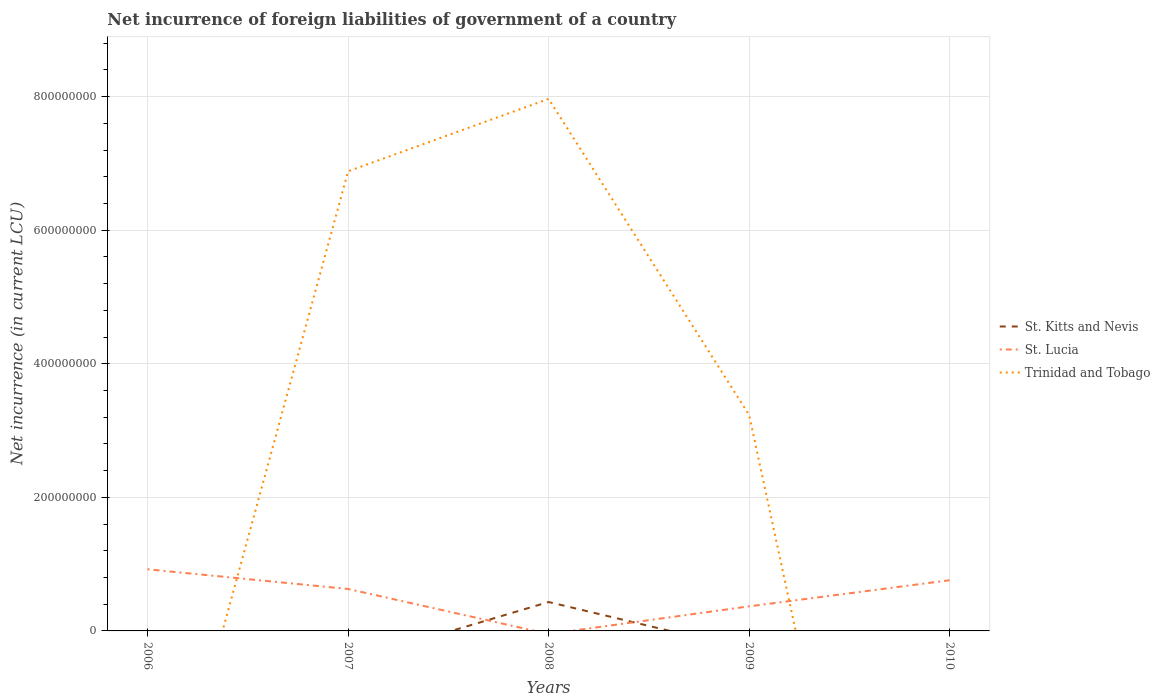How many different coloured lines are there?
Ensure brevity in your answer.  3. Across all years, what is the maximum net incurrence of foreign liabilities in St. Kitts and Nevis?
Make the answer very short. 0. What is the total net incurrence of foreign liabilities in Trinidad and Tobago in the graph?
Give a very brief answer. 4.73e+08. What is the difference between the highest and the second highest net incurrence of foreign liabilities in Trinidad and Tobago?
Make the answer very short. 7.97e+08. Is the net incurrence of foreign liabilities in Trinidad and Tobago strictly greater than the net incurrence of foreign liabilities in St. Kitts and Nevis over the years?
Your answer should be compact. No. How many lines are there?
Provide a succinct answer. 3. How many years are there in the graph?
Provide a short and direct response. 5. What is the difference between two consecutive major ticks on the Y-axis?
Provide a short and direct response. 2.00e+08. Are the values on the major ticks of Y-axis written in scientific E-notation?
Make the answer very short. No. Does the graph contain any zero values?
Offer a terse response. Yes. Does the graph contain grids?
Keep it short and to the point. Yes. Where does the legend appear in the graph?
Keep it short and to the point. Center right. What is the title of the graph?
Give a very brief answer. Net incurrence of foreign liabilities of government of a country. Does "St. Martin (French part)" appear as one of the legend labels in the graph?
Give a very brief answer. No. What is the label or title of the Y-axis?
Your answer should be very brief. Net incurrence (in current LCU). What is the Net incurrence (in current LCU) of St. Kitts and Nevis in 2006?
Your answer should be very brief. 0. What is the Net incurrence (in current LCU) of St. Lucia in 2006?
Your answer should be compact. 9.23e+07. What is the Net incurrence (in current LCU) of Trinidad and Tobago in 2006?
Your response must be concise. 0. What is the Net incurrence (in current LCU) in St. Kitts and Nevis in 2007?
Provide a succinct answer. 0. What is the Net incurrence (in current LCU) of St. Lucia in 2007?
Provide a short and direct response. 6.28e+07. What is the Net incurrence (in current LCU) of Trinidad and Tobago in 2007?
Your response must be concise. 6.88e+08. What is the Net incurrence (in current LCU) in St. Kitts and Nevis in 2008?
Make the answer very short. 4.33e+07. What is the Net incurrence (in current LCU) in Trinidad and Tobago in 2008?
Provide a short and direct response. 7.97e+08. What is the Net incurrence (in current LCU) of St. Kitts and Nevis in 2009?
Your answer should be compact. 0. What is the Net incurrence (in current LCU) of St. Lucia in 2009?
Give a very brief answer. 3.68e+07. What is the Net incurrence (in current LCU) of Trinidad and Tobago in 2009?
Keep it short and to the point. 3.23e+08. What is the Net incurrence (in current LCU) of St. Lucia in 2010?
Offer a terse response. 7.59e+07. Across all years, what is the maximum Net incurrence (in current LCU) of St. Kitts and Nevis?
Make the answer very short. 4.33e+07. Across all years, what is the maximum Net incurrence (in current LCU) in St. Lucia?
Provide a succinct answer. 9.23e+07. Across all years, what is the maximum Net incurrence (in current LCU) of Trinidad and Tobago?
Your answer should be compact. 7.97e+08. Across all years, what is the minimum Net incurrence (in current LCU) of St. Kitts and Nevis?
Provide a succinct answer. 0. Across all years, what is the minimum Net incurrence (in current LCU) of Trinidad and Tobago?
Provide a succinct answer. 0. What is the total Net incurrence (in current LCU) in St. Kitts and Nevis in the graph?
Your answer should be compact. 4.33e+07. What is the total Net incurrence (in current LCU) in St. Lucia in the graph?
Your answer should be very brief. 2.68e+08. What is the total Net incurrence (in current LCU) in Trinidad and Tobago in the graph?
Keep it short and to the point. 1.81e+09. What is the difference between the Net incurrence (in current LCU) in St. Lucia in 2006 and that in 2007?
Provide a succinct answer. 2.95e+07. What is the difference between the Net incurrence (in current LCU) in St. Lucia in 2006 and that in 2009?
Offer a terse response. 5.55e+07. What is the difference between the Net incurrence (in current LCU) of St. Lucia in 2006 and that in 2010?
Make the answer very short. 1.64e+07. What is the difference between the Net incurrence (in current LCU) of Trinidad and Tobago in 2007 and that in 2008?
Give a very brief answer. -1.08e+08. What is the difference between the Net incurrence (in current LCU) in St. Lucia in 2007 and that in 2009?
Provide a succinct answer. 2.60e+07. What is the difference between the Net incurrence (in current LCU) in Trinidad and Tobago in 2007 and that in 2009?
Ensure brevity in your answer.  3.65e+08. What is the difference between the Net incurrence (in current LCU) in St. Lucia in 2007 and that in 2010?
Offer a very short reply. -1.31e+07. What is the difference between the Net incurrence (in current LCU) in Trinidad and Tobago in 2008 and that in 2009?
Offer a very short reply. 4.73e+08. What is the difference between the Net incurrence (in current LCU) in St. Lucia in 2009 and that in 2010?
Make the answer very short. -3.91e+07. What is the difference between the Net incurrence (in current LCU) in St. Lucia in 2006 and the Net incurrence (in current LCU) in Trinidad and Tobago in 2007?
Offer a terse response. -5.96e+08. What is the difference between the Net incurrence (in current LCU) in St. Lucia in 2006 and the Net incurrence (in current LCU) in Trinidad and Tobago in 2008?
Your response must be concise. -7.04e+08. What is the difference between the Net incurrence (in current LCU) in St. Lucia in 2006 and the Net incurrence (in current LCU) in Trinidad and Tobago in 2009?
Offer a terse response. -2.31e+08. What is the difference between the Net incurrence (in current LCU) of St. Lucia in 2007 and the Net incurrence (in current LCU) of Trinidad and Tobago in 2008?
Keep it short and to the point. -7.34e+08. What is the difference between the Net incurrence (in current LCU) of St. Lucia in 2007 and the Net incurrence (in current LCU) of Trinidad and Tobago in 2009?
Make the answer very short. -2.60e+08. What is the difference between the Net incurrence (in current LCU) in St. Kitts and Nevis in 2008 and the Net incurrence (in current LCU) in St. Lucia in 2009?
Make the answer very short. 6.50e+06. What is the difference between the Net incurrence (in current LCU) of St. Kitts and Nevis in 2008 and the Net incurrence (in current LCU) of Trinidad and Tobago in 2009?
Your answer should be compact. -2.80e+08. What is the difference between the Net incurrence (in current LCU) in St. Kitts and Nevis in 2008 and the Net incurrence (in current LCU) in St. Lucia in 2010?
Make the answer very short. -3.26e+07. What is the average Net incurrence (in current LCU) in St. Kitts and Nevis per year?
Ensure brevity in your answer.  8.66e+06. What is the average Net incurrence (in current LCU) of St. Lucia per year?
Your response must be concise. 5.36e+07. What is the average Net incurrence (in current LCU) in Trinidad and Tobago per year?
Make the answer very short. 3.62e+08. In the year 2007, what is the difference between the Net incurrence (in current LCU) in St. Lucia and Net incurrence (in current LCU) in Trinidad and Tobago?
Make the answer very short. -6.26e+08. In the year 2008, what is the difference between the Net incurrence (in current LCU) in St. Kitts and Nevis and Net incurrence (in current LCU) in Trinidad and Tobago?
Your response must be concise. -7.53e+08. In the year 2009, what is the difference between the Net incurrence (in current LCU) in St. Lucia and Net incurrence (in current LCU) in Trinidad and Tobago?
Provide a short and direct response. -2.86e+08. What is the ratio of the Net incurrence (in current LCU) in St. Lucia in 2006 to that in 2007?
Your response must be concise. 1.47. What is the ratio of the Net incurrence (in current LCU) of St. Lucia in 2006 to that in 2009?
Your response must be concise. 2.51. What is the ratio of the Net incurrence (in current LCU) of St. Lucia in 2006 to that in 2010?
Provide a succinct answer. 1.22. What is the ratio of the Net incurrence (in current LCU) in Trinidad and Tobago in 2007 to that in 2008?
Your answer should be very brief. 0.86. What is the ratio of the Net incurrence (in current LCU) of St. Lucia in 2007 to that in 2009?
Your answer should be very brief. 1.71. What is the ratio of the Net incurrence (in current LCU) of Trinidad and Tobago in 2007 to that in 2009?
Your answer should be very brief. 2.13. What is the ratio of the Net incurrence (in current LCU) in St. Lucia in 2007 to that in 2010?
Your response must be concise. 0.83. What is the ratio of the Net incurrence (in current LCU) in Trinidad and Tobago in 2008 to that in 2009?
Your answer should be compact. 2.46. What is the ratio of the Net incurrence (in current LCU) in St. Lucia in 2009 to that in 2010?
Offer a very short reply. 0.48. What is the difference between the highest and the second highest Net incurrence (in current LCU) in St. Lucia?
Keep it short and to the point. 1.64e+07. What is the difference between the highest and the second highest Net incurrence (in current LCU) in Trinidad and Tobago?
Make the answer very short. 1.08e+08. What is the difference between the highest and the lowest Net incurrence (in current LCU) of St. Kitts and Nevis?
Your answer should be compact. 4.33e+07. What is the difference between the highest and the lowest Net incurrence (in current LCU) of St. Lucia?
Provide a short and direct response. 9.23e+07. What is the difference between the highest and the lowest Net incurrence (in current LCU) in Trinidad and Tobago?
Offer a terse response. 7.97e+08. 